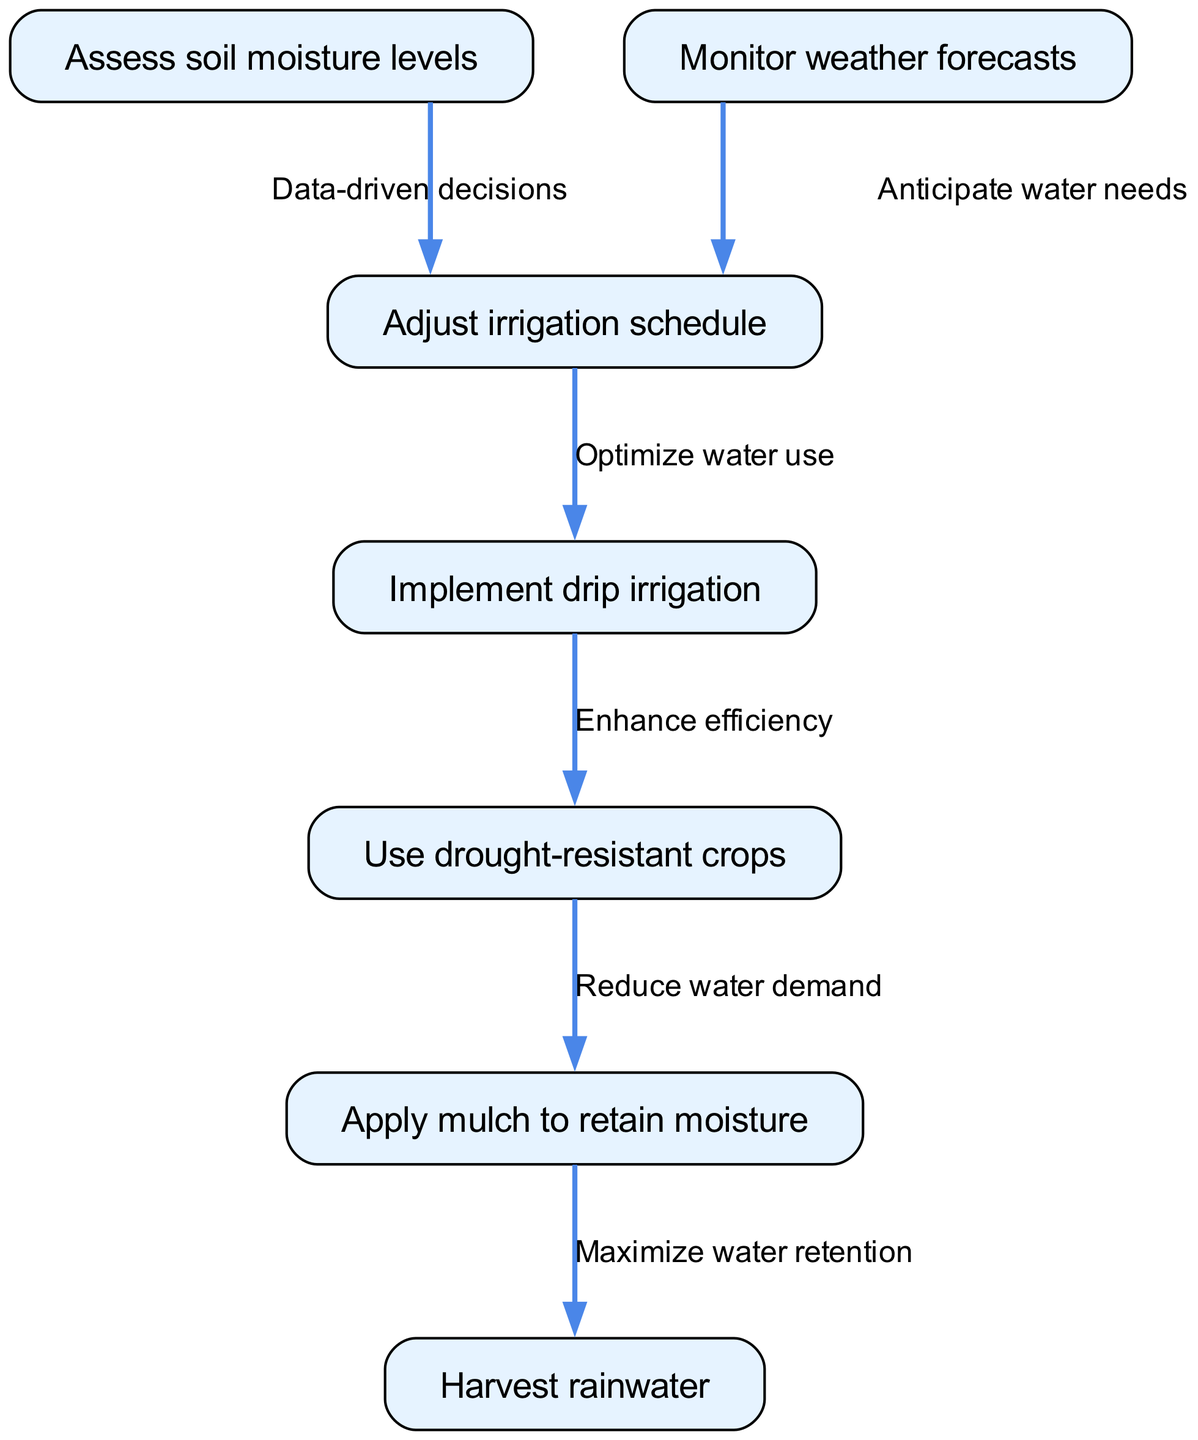What is the first step in the water conservation strategy? The diagram starts with assessing soil moisture levels, which is indicated as the first node in the pathway.
Answer: Assess soil moisture levels How many nodes are present in the diagram? By counting each unique step or action in the diagram's nodes, we find that there are a total of 7 nodes.
Answer: 7 What action follows monitoring weather forecasts? The edge that connects the monitoring weather forecasts node to the next indicates that the subsequent action is to adjust the irrigation schedule, which is the node linked to it.
Answer: Adjust irrigation schedule Which node leads to implementing drip irrigation? The implementation of drip irrigation is directly related to adjusting the irrigation schedule, and it follows from this action according to the edges in the diagram.
Answer: Adjust irrigation schedule What is the relationship between applying mulch and harvesting rainwater? The edge connecting applying mulch to harvesting rainwater indicates a flow where applying mulch is aimed at maximizing water retention, which leads to the action of harvesting rainwater.
Answer: Maximize water retention What are two methods used to reduce water demand in this plan? The diagram shows that two methods for reducing water demand are using drought-resistant crops and applying mulch to retain moisture, as these are the steps that lead to reduced water needs.
Answer: Use drought-resistant crops, Apply mulch to retain moisture What comes after optimizing water use? According to the diagram, after optimizing water use, the next step is to enhance efficiency by implementing drip irrigation.
Answer: Enhance efficiency Which two nodes are linked by the relationship "Data-driven decisions"? The "Data-driven decisions" relationship connects the step of assessing soil moisture levels to adjusting the irrigation schedule, as marked by the edge in the diagram.
Answer: Assess soil moisture levels, Adjust irrigation schedule 